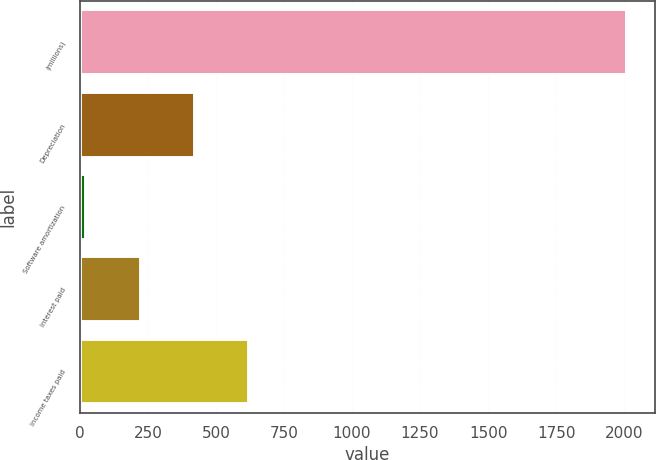Convert chart to OTSL. <chart><loc_0><loc_0><loc_500><loc_500><bar_chart><fcel>(millions)<fcel>Depreciation<fcel>Software amortization<fcel>Interest paid<fcel>Income taxes paid<nl><fcel>2011<fcel>421.72<fcel>24.4<fcel>223.06<fcel>620.38<nl></chart> 